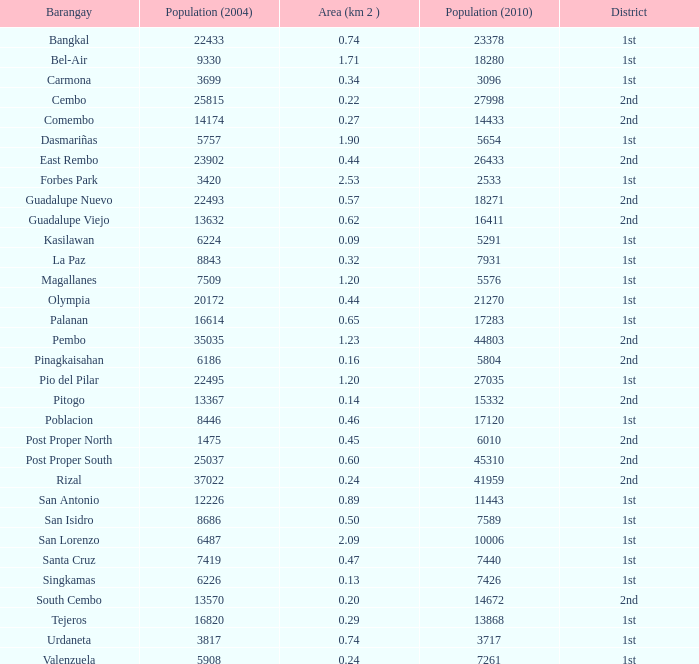What is the area where barangay is guadalupe viejo? 0.62. 